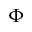<formula> <loc_0><loc_0><loc_500><loc_500>\Phi</formula> 